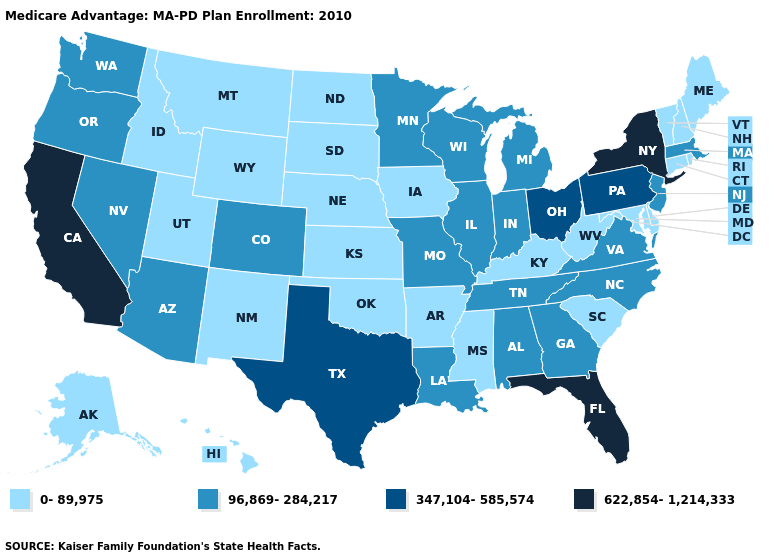What is the value of Wisconsin?
Short answer required. 96,869-284,217. Does Missouri have the same value as Maine?
Give a very brief answer. No. What is the highest value in the South ?
Concise answer only. 622,854-1,214,333. What is the lowest value in the USA?
Keep it brief. 0-89,975. What is the value of Connecticut?
Quick response, please. 0-89,975. How many symbols are there in the legend?
Keep it brief. 4. Does Michigan have the lowest value in the MidWest?
Quick response, please. No. Does the first symbol in the legend represent the smallest category?
Quick response, please. Yes. What is the value of New York?
Concise answer only. 622,854-1,214,333. What is the value of Georgia?
Write a very short answer. 96,869-284,217. Does Oregon have the highest value in the USA?
Concise answer only. No. What is the value of Wyoming?
Concise answer only. 0-89,975. What is the highest value in states that border Georgia?
Keep it brief. 622,854-1,214,333. What is the lowest value in states that border North Carolina?
Concise answer only. 0-89,975. 